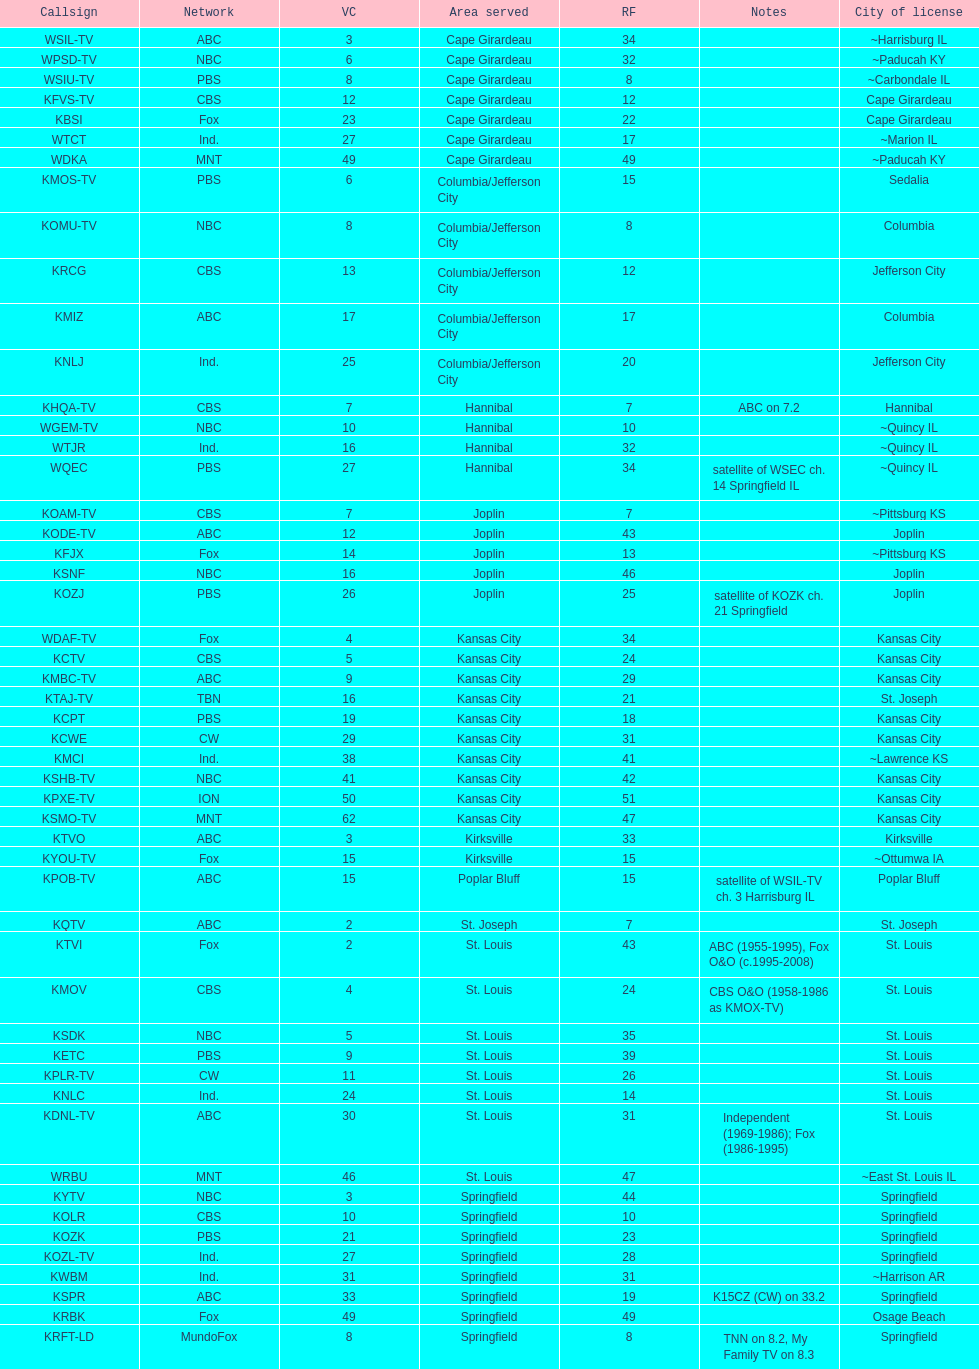Kode-tv and wsil-tv both are a part of which network? ABC. 